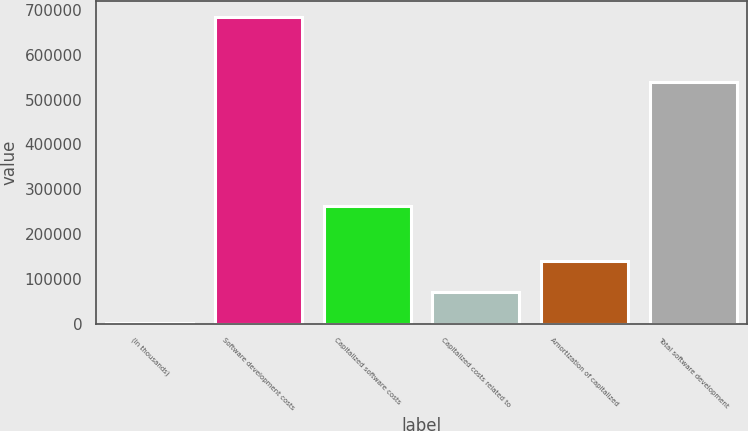Convert chart to OTSL. <chart><loc_0><loc_0><loc_500><loc_500><bar_chart><fcel>(In thousands)<fcel>Software development costs<fcel>Capitalized software costs<fcel>Capitalized costs related to<fcel>Amortization of capitalized<fcel>Total software development<nl><fcel>2015<fcel>685260<fcel>262177<fcel>70339.5<fcel>138664<fcel>539799<nl></chart> 